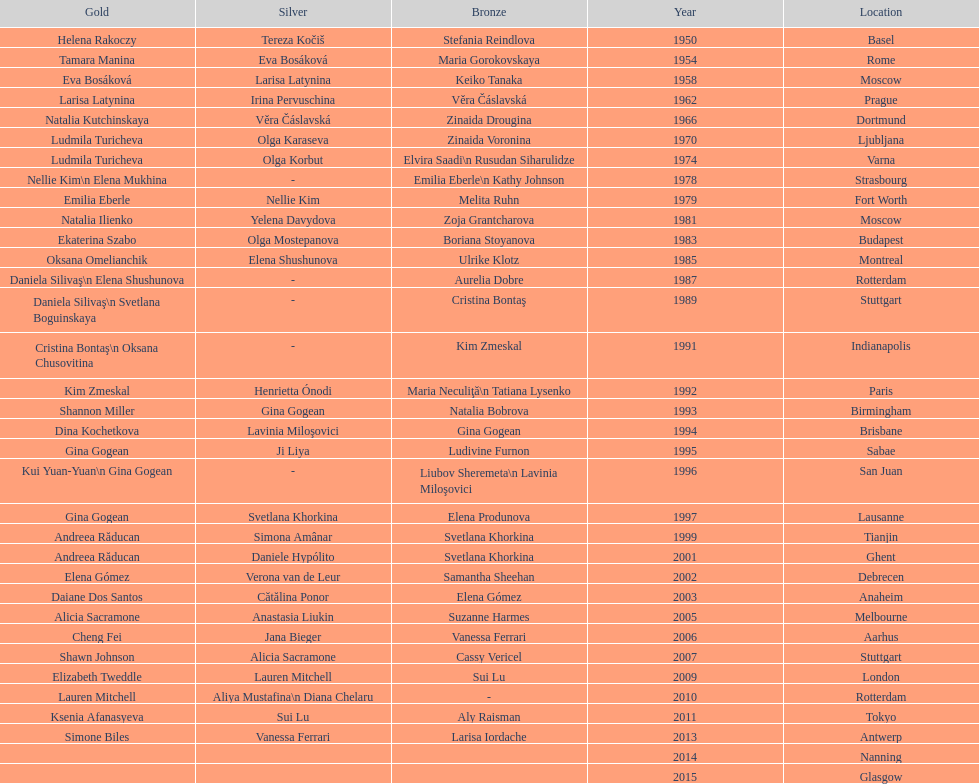How long is the time between the times the championship was held in moscow? 23 years. 